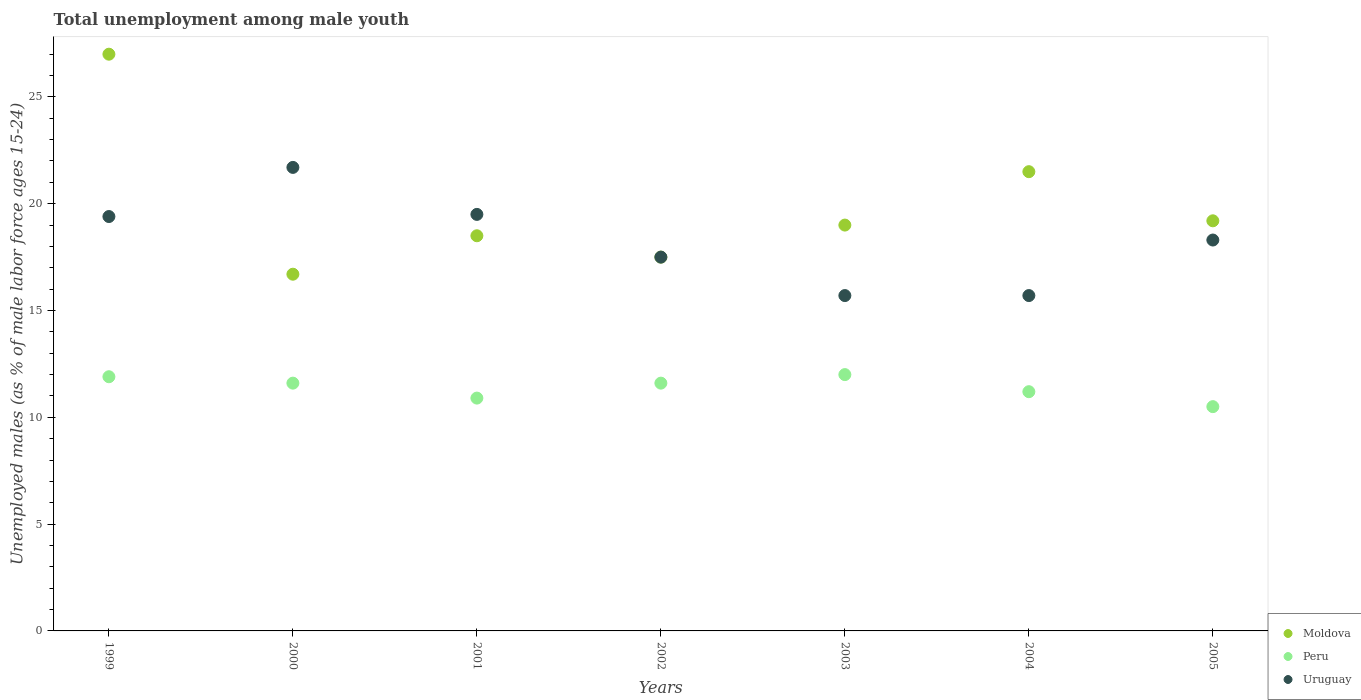How many different coloured dotlines are there?
Provide a short and direct response. 3. What is the percentage of unemployed males in in Peru in 2004?
Ensure brevity in your answer.  11.2. Across all years, what is the maximum percentage of unemployed males in in Moldova?
Keep it short and to the point. 27. Across all years, what is the minimum percentage of unemployed males in in Uruguay?
Your response must be concise. 15.7. In which year was the percentage of unemployed males in in Uruguay minimum?
Ensure brevity in your answer.  2003. What is the total percentage of unemployed males in in Moldova in the graph?
Keep it short and to the point. 139.4. What is the difference between the percentage of unemployed males in in Uruguay in 2000 and that in 2004?
Your response must be concise. 6. What is the difference between the percentage of unemployed males in in Moldova in 2000 and the percentage of unemployed males in in Uruguay in 2001?
Offer a very short reply. -2.8. What is the average percentage of unemployed males in in Peru per year?
Keep it short and to the point. 11.39. In the year 2003, what is the difference between the percentage of unemployed males in in Uruguay and percentage of unemployed males in in Moldova?
Make the answer very short. -3.3. In how many years, is the percentage of unemployed males in in Peru greater than 26 %?
Provide a short and direct response. 0. What is the ratio of the percentage of unemployed males in in Moldova in 2000 to that in 2004?
Ensure brevity in your answer.  0.78. Is the percentage of unemployed males in in Moldova in 2001 less than that in 2002?
Make the answer very short. No. Is the difference between the percentage of unemployed males in in Uruguay in 2004 and 2005 greater than the difference between the percentage of unemployed males in in Moldova in 2004 and 2005?
Offer a very short reply. No. What is the difference between the highest and the second highest percentage of unemployed males in in Peru?
Provide a short and direct response. 0.1. What is the difference between the highest and the lowest percentage of unemployed males in in Peru?
Give a very brief answer. 1.5. In how many years, is the percentage of unemployed males in in Uruguay greater than the average percentage of unemployed males in in Uruguay taken over all years?
Offer a very short reply. 4. Is the sum of the percentage of unemployed males in in Peru in 1999 and 2000 greater than the maximum percentage of unemployed males in in Moldova across all years?
Make the answer very short. No. Is the percentage of unemployed males in in Uruguay strictly greater than the percentage of unemployed males in in Peru over the years?
Make the answer very short. Yes. Is the percentage of unemployed males in in Moldova strictly less than the percentage of unemployed males in in Peru over the years?
Offer a very short reply. No. How many years are there in the graph?
Give a very brief answer. 7. Does the graph contain any zero values?
Your answer should be compact. No. Does the graph contain grids?
Your response must be concise. No. Where does the legend appear in the graph?
Make the answer very short. Bottom right. How are the legend labels stacked?
Make the answer very short. Vertical. What is the title of the graph?
Your answer should be compact. Total unemployment among male youth. What is the label or title of the X-axis?
Offer a terse response. Years. What is the label or title of the Y-axis?
Offer a very short reply. Unemployed males (as % of male labor force ages 15-24). What is the Unemployed males (as % of male labor force ages 15-24) of Peru in 1999?
Your answer should be very brief. 11.9. What is the Unemployed males (as % of male labor force ages 15-24) of Uruguay in 1999?
Give a very brief answer. 19.4. What is the Unemployed males (as % of male labor force ages 15-24) of Moldova in 2000?
Your answer should be compact. 16.7. What is the Unemployed males (as % of male labor force ages 15-24) of Peru in 2000?
Give a very brief answer. 11.6. What is the Unemployed males (as % of male labor force ages 15-24) of Uruguay in 2000?
Keep it short and to the point. 21.7. What is the Unemployed males (as % of male labor force ages 15-24) in Peru in 2001?
Make the answer very short. 10.9. What is the Unemployed males (as % of male labor force ages 15-24) in Uruguay in 2001?
Your answer should be compact. 19.5. What is the Unemployed males (as % of male labor force ages 15-24) in Moldova in 2002?
Provide a succinct answer. 17.5. What is the Unemployed males (as % of male labor force ages 15-24) of Peru in 2002?
Your answer should be very brief. 11.6. What is the Unemployed males (as % of male labor force ages 15-24) in Uruguay in 2002?
Provide a short and direct response. 17.5. What is the Unemployed males (as % of male labor force ages 15-24) of Moldova in 2003?
Make the answer very short. 19. What is the Unemployed males (as % of male labor force ages 15-24) of Uruguay in 2003?
Ensure brevity in your answer.  15.7. What is the Unemployed males (as % of male labor force ages 15-24) in Peru in 2004?
Offer a terse response. 11.2. What is the Unemployed males (as % of male labor force ages 15-24) in Uruguay in 2004?
Your answer should be compact. 15.7. What is the Unemployed males (as % of male labor force ages 15-24) of Moldova in 2005?
Provide a short and direct response. 19.2. What is the Unemployed males (as % of male labor force ages 15-24) in Peru in 2005?
Offer a terse response. 10.5. What is the Unemployed males (as % of male labor force ages 15-24) in Uruguay in 2005?
Keep it short and to the point. 18.3. Across all years, what is the maximum Unemployed males (as % of male labor force ages 15-24) of Moldova?
Your answer should be very brief. 27. Across all years, what is the maximum Unemployed males (as % of male labor force ages 15-24) in Peru?
Keep it short and to the point. 12. Across all years, what is the maximum Unemployed males (as % of male labor force ages 15-24) in Uruguay?
Provide a succinct answer. 21.7. Across all years, what is the minimum Unemployed males (as % of male labor force ages 15-24) in Moldova?
Offer a very short reply. 16.7. Across all years, what is the minimum Unemployed males (as % of male labor force ages 15-24) in Uruguay?
Ensure brevity in your answer.  15.7. What is the total Unemployed males (as % of male labor force ages 15-24) in Moldova in the graph?
Your response must be concise. 139.4. What is the total Unemployed males (as % of male labor force ages 15-24) in Peru in the graph?
Your response must be concise. 79.7. What is the total Unemployed males (as % of male labor force ages 15-24) in Uruguay in the graph?
Your answer should be compact. 127.8. What is the difference between the Unemployed males (as % of male labor force ages 15-24) of Peru in 1999 and that in 2000?
Provide a succinct answer. 0.3. What is the difference between the Unemployed males (as % of male labor force ages 15-24) in Moldova in 1999 and that in 2001?
Keep it short and to the point. 8.5. What is the difference between the Unemployed males (as % of male labor force ages 15-24) of Peru in 1999 and that in 2001?
Offer a very short reply. 1. What is the difference between the Unemployed males (as % of male labor force ages 15-24) in Moldova in 1999 and that in 2002?
Your response must be concise. 9.5. What is the difference between the Unemployed males (as % of male labor force ages 15-24) in Peru in 1999 and that in 2003?
Give a very brief answer. -0.1. What is the difference between the Unemployed males (as % of male labor force ages 15-24) in Moldova in 1999 and that in 2004?
Keep it short and to the point. 5.5. What is the difference between the Unemployed males (as % of male labor force ages 15-24) in Peru in 1999 and that in 2004?
Give a very brief answer. 0.7. What is the difference between the Unemployed males (as % of male labor force ages 15-24) of Uruguay in 1999 and that in 2004?
Ensure brevity in your answer.  3.7. What is the difference between the Unemployed males (as % of male labor force ages 15-24) of Peru in 1999 and that in 2005?
Your answer should be compact. 1.4. What is the difference between the Unemployed males (as % of male labor force ages 15-24) of Moldova in 2000 and that in 2001?
Keep it short and to the point. -1.8. What is the difference between the Unemployed males (as % of male labor force ages 15-24) of Peru in 2000 and that in 2001?
Make the answer very short. 0.7. What is the difference between the Unemployed males (as % of male labor force ages 15-24) of Uruguay in 2000 and that in 2002?
Give a very brief answer. 4.2. What is the difference between the Unemployed males (as % of male labor force ages 15-24) in Moldova in 2000 and that in 2003?
Your response must be concise. -2.3. What is the difference between the Unemployed males (as % of male labor force ages 15-24) of Peru in 2000 and that in 2003?
Give a very brief answer. -0.4. What is the difference between the Unemployed males (as % of male labor force ages 15-24) in Uruguay in 2000 and that in 2003?
Offer a very short reply. 6. What is the difference between the Unemployed males (as % of male labor force ages 15-24) in Uruguay in 2000 and that in 2004?
Make the answer very short. 6. What is the difference between the Unemployed males (as % of male labor force ages 15-24) in Uruguay in 2000 and that in 2005?
Give a very brief answer. 3.4. What is the difference between the Unemployed males (as % of male labor force ages 15-24) in Moldova in 2001 and that in 2002?
Make the answer very short. 1. What is the difference between the Unemployed males (as % of male labor force ages 15-24) in Peru in 2001 and that in 2002?
Offer a terse response. -0.7. What is the difference between the Unemployed males (as % of male labor force ages 15-24) of Peru in 2001 and that in 2003?
Give a very brief answer. -1.1. What is the difference between the Unemployed males (as % of male labor force ages 15-24) in Moldova in 2001 and that in 2004?
Your response must be concise. -3. What is the difference between the Unemployed males (as % of male labor force ages 15-24) of Moldova in 2001 and that in 2005?
Make the answer very short. -0.7. What is the difference between the Unemployed males (as % of male labor force ages 15-24) in Peru in 2001 and that in 2005?
Keep it short and to the point. 0.4. What is the difference between the Unemployed males (as % of male labor force ages 15-24) in Peru in 2002 and that in 2003?
Give a very brief answer. -0.4. What is the difference between the Unemployed males (as % of male labor force ages 15-24) in Moldova in 2002 and that in 2004?
Give a very brief answer. -4. What is the difference between the Unemployed males (as % of male labor force ages 15-24) of Moldova in 2002 and that in 2005?
Keep it short and to the point. -1.7. What is the difference between the Unemployed males (as % of male labor force ages 15-24) of Peru in 2002 and that in 2005?
Make the answer very short. 1.1. What is the difference between the Unemployed males (as % of male labor force ages 15-24) of Moldova in 2003 and that in 2004?
Make the answer very short. -2.5. What is the difference between the Unemployed males (as % of male labor force ages 15-24) of Uruguay in 2003 and that in 2005?
Your response must be concise. -2.6. What is the difference between the Unemployed males (as % of male labor force ages 15-24) in Peru in 2004 and that in 2005?
Your answer should be compact. 0.7. What is the difference between the Unemployed males (as % of male labor force ages 15-24) of Peru in 1999 and the Unemployed males (as % of male labor force ages 15-24) of Uruguay in 2001?
Provide a short and direct response. -7.6. What is the difference between the Unemployed males (as % of male labor force ages 15-24) of Moldova in 1999 and the Unemployed males (as % of male labor force ages 15-24) of Uruguay in 2002?
Your answer should be very brief. 9.5. What is the difference between the Unemployed males (as % of male labor force ages 15-24) of Moldova in 1999 and the Unemployed males (as % of male labor force ages 15-24) of Peru in 2003?
Ensure brevity in your answer.  15. What is the difference between the Unemployed males (as % of male labor force ages 15-24) in Moldova in 1999 and the Unemployed males (as % of male labor force ages 15-24) in Uruguay in 2003?
Ensure brevity in your answer.  11.3. What is the difference between the Unemployed males (as % of male labor force ages 15-24) of Peru in 1999 and the Unemployed males (as % of male labor force ages 15-24) of Uruguay in 2003?
Provide a succinct answer. -3.8. What is the difference between the Unemployed males (as % of male labor force ages 15-24) of Peru in 1999 and the Unemployed males (as % of male labor force ages 15-24) of Uruguay in 2004?
Your answer should be very brief. -3.8. What is the difference between the Unemployed males (as % of male labor force ages 15-24) of Moldova in 1999 and the Unemployed males (as % of male labor force ages 15-24) of Uruguay in 2005?
Your answer should be very brief. 8.7. What is the difference between the Unemployed males (as % of male labor force ages 15-24) of Moldova in 2000 and the Unemployed males (as % of male labor force ages 15-24) of Peru in 2001?
Offer a very short reply. 5.8. What is the difference between the Unemployed males (as % of male labor force ages 15-24) in Moldova in 2000 and the Unemployed males (as % of male labor force ages 15-24) in Uruguay in 2001?
Your response must be concise. -2.8. What is the difference between the Unemployed males (as % of male labor force ages 15-24) of Moldova in 2000 and the Unemployed males (as % of male labor force ages 15-24) of Peru in 2002?
Your answer should be compact. 5.1. What is the difference between the Unemployed males (as % of male labor force ages 15-24) of Moldova in 2000 and the Unemployed males (as % of male labor force ages 15-24) of Peru in 2003?
Offer a very short reply. 4.7. What is the difference between the Unemployed males (as % of male labor force ages 15-24) of Peru in 2000 and the Unemployed males (as % of male labor force ages 15-24) of Uruguay in 2003?
Your answer should be compact. -4.1. What is the difference between the Unemployed males (as % of male labor force ages 15-24) of Moldova in 2000 and the Unemployed males (as % of male labor force ages 15-24) of Peru in 2004?
Your answer should be very brief. 5.5. What is the difference between the Unemployed males (as % of male labor force ages 15-24) in Moldova in 2001 and the Unemployed males (as % of male labor force ages 15-24) in Peru in 2002?
Make the answer very short. 6.9. What is the difference between the Unemployed males (as % of male labor force ages 15-24) in Moldova in 2001 and the Unemployed males (as % of male labor force ages 15-24) in Uruguay in 2002?
Keep it short and to the point. 1. What is the difference between the Unemployed males (as % of male labor force ages 15-24) in Moldova in 2001 and the Unemployed males (as % of male labor force ages 15-24) in Peru in 2003?
Make the answer very short. 6.5. What is the difference between the Unemployed males (as % of male labor force ages 15-24) in Peru in 2001 and the Unemployed males (as % of male labor force ages 15-24) in Uruguay in 2003?
Offer a very short reply. -4.8. What is the difference between the Unemployed males (as % of male labor force ages 15-24) in Moldova in 2001 and the Unemployed males (as % of male labor force ages 15-24) in Peru in 2005?
Offer a terse response. 8. What is the difference between the Unemployed males (as % of male labor force ages 15-24) in Moldova in 2001 and the Unemployed males (as % of male labor force ages 15-24) in Uruguay in 2005?
Offer a terse response. 0.2. What is the difference between the Unemployed males (as % of male labor force ages 15-24) of Peru in 2001 and the Unemployed males (as % of male labor force ages 15-24) of Uruguay in 2005?
Ensure brevity in your answer.  -7.4. What is the difference between the Unemployed males (as % of male labor force ages 15-24) of Moldova in 2002 and the Unemployed males (as % of male labor force ages 15-24) of Uruguay in 2003?
Ensure brevity in your answer.  1.8. What is the difference between the Unemployed males (as % of male labor force ages 15-24) of Peru in 2002 and the Unemployed males (as % of male labor force ages 15-24) of Uruguay in 2003?
Your answer should be compact. -4.1. What is the difference between the Unemployed males (as % of male labor force ages 15-24) of Moldova in 2002 and the Unemployed males (as % of male labor force ages 15-24) of Peru in 2004?
Offer a very short reply. 6.3. What is the difference between the Unemployed males (as % of male labor force ages 15-24) of Moldova in 2002 and the Unemployed males (as % of male labor force ages 15-24) of Uruguay in 2004?
Offer a very short reply. 1.8. What is the difference between the Unemployed males (as % of male labor force ages 15-24) of Moldova in 2002 and the Unemployed males (as % of male labor force ages 15-24) of Uruguay in 2005?
Provide a succinct answer. -0.8. What is the difference between the Unemployed males (as % of male labor force ages 15-24) in Moldova in 2003 and the Unemployed males (as % of male labor force ages 15-24) in Peru in 2004?
Give a very brief answer. 7.8. What is the difference between the Unemployed males (as % of male labor force ages 15-24) of Moldova in 2003 and the Unemployed males (as % of male labor force ages 15-24) of Uruguay in 2004?
Provide a succinct answer. 3.3. What is the difference between the Unemployed males (as % of male labor force ages 15-24) of Peru in 2003 and the Unemployed males (as % of male labor force ages 15-24) of Uruguay in 2004?
Give a very brief answer. -3.7. What is the difference between the Unemployed males (as % of male labor force ages 15-24) in Moldova in 2003 and the Unemployed males (as % of male labor force ages 15-24) in Peru in 2005?
Offer a terse response. 8.5. What is the difference between the Unemployed males (as % of male labor force ages 15-24) in Peru in 2004 and the Unemployed males (as % of male labor force ages 15-24) in Uruguay in 2005?
Provide a succinct answer. -7.1. What is the average Unemployed males (as % of male labor force ages 15-24) of Moldova per year?
Give a very brief answer. 19.91. What is the average Unemployed males (as % of male labor force ages 15-24) of Peru per year?
Provide a succinct answer. 11.39. What is the average Unemployed males (as % of male labor force ages 15-24) of Uruguay per year?
Keep it short and to the point. 18.26. In the year 1999, what is the difference between the Unemployed males (as % of male labor force ages 15-24) of Moldova and Unemployed males (as % of male labor force ages 15-24) of Peru?
Your answer should be very brief. 15.1. In the year 2000, what is the difference between the Unemployed males (as % of male labor force ages 15-24) of Moldova and Unemployed males (as % of male labor force ages 15-24) of Peru?
Your answer should be compact. 5.1. In the year 2001, what is the difference between the Unemployed males (as % of male labor force ages 15-24) in Moldova and Unemployed males (as % of male labor force ages 15-24) in Uruguay?
Your answer should be very brief. -1. In the year 2001, what is the difference between the Unemployed males (as % of male labor force ages 15-24) of Peru and Unemployed males (as % of male labor force ages 15-24) of Uruguay?
Give a very brief answer. -8.6. In the year 2002, what is the difference between the Unemployed males (as % of male labor force ages 15-24) in Moldova and Unemployed males (as % of male labor force ages 15-24) in Peru?
Provide a succinct answer. 5.9. In the year 2002, what is the difference between the Unemployed males (as % of male labor force ages 15-24) in Moldova and Unemployed males (as % of male labor force ages 15-24) in Uruguay?
Make the answer very short. 0. In the year 2002, what is the difference between the Unemployed males (as % of male labor force ages 15-24) of Peru and Unemployed males (as % of male labor force ages 15-24) of Uruguay?
Offer a terse response. -5.9. In the year 2004, what is the difference between the Unemployed males (as % of male labor force ages 15-24) of Moldova and Unemployed males (as % of male labor force ages 15-24) of Peru?
Provide a short and direct response. 10.3. In the year 2004, what is the difference between the Unemployed males (as % of male labor force ages 15-24) of Moldova and Unemployed males (as % of male labor force ages 15-24) of Uruguay?
Ensure brevity in your answer.  5.8. In the year 2005, what is the difference between the Unemployed males (as % of male labor force ages 15-24) in Moldova and Unemployed males (as % of male labor force ages 15-24) in Uruguay?
Provide a succinct answer. 0.9. In the year 2005, what is the difference between the Unemployed males (as % of male labor force ages 15-24) of Peru and Unemployed males (as % of male labor force ages 15-24) of Uruguay?
Your response must be concise. -7.8. What is the ratio of the Unemployed males (as % of male labor force ages 15-24) of Moldova in 1999 to that in 2000?
Make the answer very short. 1.62. What is the ratio of the Unemployed males (as % of male labor force ages 15-24) in Peru in 1999 to that in 2000?
Your response must be concise. 1.03. What is the ratio of the Unemployed males (as % of male labor force ages 15-24) in Uruguay in 1999 to that in 2000?
Provide a short and direct response. 0.89. What is the ratio of the Unemployed males (as % of male labor force ages 15-24) of Moldova in 1999 to that in 2001?
Offer a terse response. 1.46. What is the ratio of the Unemployed males (as % of male labor force ages 15-24) in Peru in 1999 to that in 2001?
Give a very brief answer. 1.09. What is the ratio of the Unemployed males (as % of male labor force ages 15-24) in Uruguay in 1999 to that in 2001?
Your answer should be compact. 0.99. What is the ratio of the Unemployed males (as % of male labor force ages 15-24) in Moldova in 1999 to that in 2002?
Provide a succinct answer. 1.54. What is the ratio of the Unemployed males (as % of male labor force ages 15-24) of Peru in 1999 to that in 2002?
Provide a succinct answer. 1.03. What is the ratio of the Unemployed males (as % of male labor force ages 15-24) in Uruguay in 1999 to that in 2002?
Provide a short and direct response. 1.11. What is the ratio of the Unemployed males (as % of male labor force ages 15-24) of Moldova in 1999 to that in 2003?
Offer a very short reply. 1.42. What is the ratio of the Unemployed males (as % of male labor force ages 15-24) in Peru in 1999 to that in 2003?
Make the answer very short. 0.99. What is the ratio of the Unemployed males (as % of male labor force ages 15-24) in Uruguay in 1999 to that in 2003?
Provide a short and direct response. 1.24. What is the ratio of the Unemployed males (as % of male labor force ages 15-24) of Moldova in 1999 to that in 2004?
Your answer should be compact. 1.26. What is the ratio of the Unemployed males (as % of male labor force ages 15-24) of Peru in 1999 to that in 2004?
Ensure brevity in your answer.  1.06. What is the ratio of the Unemployed males (as % of male labor force ages 15-24) in Uruguay in 1999 to that in 2004?
Your response must be concise. 1.24. What is the ratio of the Unemployed males (as % of male labor force ages 15-24) of Moldova in 1999 to that in 2005?
Ensure brevity in your answer.  1.41. What is the ratio of the Unemployed males (as % of male labor force ages 15-24) in Peru in 1999 to that in 2005?
Offer a terse response. 1.13. What is the ratio of the Unemployed males (as % of male labor force ages 15-24) in Uruguay in 1999 to that in 2005?
Your answer should be very brief. 1.06. What is the ratio of the Unemployed males (as % of male labor force ages 15-24) in Moldova in 2000 to that in 2001?
Keep it short and to the point. 0.9. What is the ratio of the Unemployed males (as % of male labor force ages 15-24) of Peru in 2000 to that in 2001?
Make the answer very short. 1.06. What is the ratio of the Unemployed males (as % of male labor force ages 15-24) in Uruguay in 2000 to that in 2001?
Keep it short and to the point. 1.11. What is the ratio of the Unemployed males (as % of male labor force ages 15-24) of Moldova in 2000 to that in 2002?
Ensure brevity in your answer.  0.95. What is the ratio of the Unemployed males (as % of male labor force ages 15-24) in Uruguay in 2000 to that in 2002?
Keep it short and to the point. 1.24. What is the ratio of the Unemployed males (as % of male labor force ages 15-24) of Moldova in 2000 to that in 2003?
Ensure brevity in your answer.  0.88. What is the ratio of the Unemployed males (as % of male labor force ages 15-24) of Peru in 2000 to that in 2003?
Provide a succinct answer. 0.97. What is the ratio of the Unemployed males (as % of male labor force ages 15-24) of Uruguay in 2000 to that in 2003?
Ensure brevity in your answer.  1.38. What is the ratio of the Unemployed males (as % of male labor force ages 15-24) in Moldova in 2000 to that in 2004?
Keep it short and to the point. 0.78. What is the ratio of the Unemployed males (as % of male labor force ages 15-24) of Peru in 2000 to that in 2004?
Offer a very short reply. 1.04. What is the ratio of the Unemployed males (as % of male labor force ages 15-24) of Uruguay in 2000 to that in 2004?
Offer a very short reply. 1.38. What is the ratio of the Unemployed males (as % of male labor force ages 15-24) of Moldova in 2000 to that in 2005?
Give a very brief answer. 0.87. What is the ratio of the Unemployed males (as % of male labor force ages 15-24) of Peru in 2000 to that in 2005?
Your response must be concise. 1.1. What is the ratio of the Unemployed males (as % of male labor force ages 15-24) in Uruguay in 2000 to that in 2005?
Ensure brevity in your answer.  1.19. What is the ratio of the Unemployed males (as % of male labor force ages 15-24) in Moldova in 2001 to that in 2002?
Your answer should be compact. 1.06. What is the ratio of the Unemployed males (as % of male labor force ages 15-24) in Peru in 2001 to that in 2002?
Provide a short and direct response. 0.94. What is the ratio of the Unemployed males (as % of male labor force ages 15-24) in Uruguay in 2001 to that in 2002?
Keep it short and to the point. 1.11. What is the ratio of the Unemployed males (as % of male labor force ages 15-24) in Moldova in 2001 to that in 2003?
Provide a short and direct response. 0.97. What is the ratio of the Unemployed males (as % of male labor force ages 15-24) in Peru in 2001 to that in 2003?
Ensure brevity in your answer.  0.91. What is the ratio of the Unemployed males (as % of male labor force ages 15-24) of Uruguay in 2001 to that in 2003?
Make the answer very short. 1.24. What is the ratio of the Unemployed males (as % of male labor force ages 15-24) in Moldova in 2001 to that in 2004?
Provide a succinct answer. 0.86. What is the ratio of the Unemployed males (as % of male labor force ages 15-24) of Peru in 2001 to that in 2004?
Your answer should be compact. 0.97. What is the ratio of the Unemployed males (as % of male labor force ages 15-24) of Uruguay in 2001 to that in 2004?
Ensure brevity in your answer.  1.24. What is the ratio of the Unemployed males (as % of male labor force ages 15-24) of Moldova in 2001 to that in 2005?
Give a very brief answer. 0.96. What is the ratio of the Unemployed males (as % of male labor force ages 15-24) of Peru in 2001 to that in 2005?
Make the answer very short. 1.04. What is the ratio of the Unemployed males (as % of male labor force ages 15-24) of Uruguay in 2001 to that in 2005?
Offer a very short reply. 1.07. What is the ratio of the Unemployed males (as % of male labor force ages 15-24) in Moldova in 2002 to that in 2003?
Give a very brief answer. 0.92. What is the ratio of the Unemployed males (as % of male labor force ages 15-24) of Peru in 2002 to that in 2003?
Provide a short and direct response. 0.97. What is the ratio of the Unemployed males (as % of male labor force ages 15-24) in Uruguay in 2002 to that in 2003?
Ensure brevity in your answer.  1.11. What is the ratio of the Unemployed males (as % of male labor force ages 15-24) in Moldova in 2002 to that in 2004?
Offer a very short reply. 0.81. What is the ratio of the Unemployed males (as % of male labor force ages 15-24) of Peru in 2002 to that in 2004?
Your answer should be compact. 1.04. What is the ratio of the Unemployed males (as % of male labor force ages 15-24) in Uruguay in 2002 to that in 2004?
Provide a succinct answer. 1.11. What is the ratio of the Unemployed males (as % of male labor force ages 15-24) in Moldova in 2002 to that in 2005?
Provide a short and direct response. 0.91. What is the ratio of the Unemployed males (as % of male labor force ages 15-24) in Peru in 2002 to that in 2005?
Your answer should be compact. 1.1. What is the ratio of the Unemployed males (as % of male labor force ages 15-24) of Uruguay in 2002 to that in 2005?
Give a very brief answer. 0.96. What is the ratio of the Unemployed males (as % of male labor force ages 15-24) in Moldova in 2003 to that in 2004?
Your answer should be very brief. 0.88. What is the ratio of the Unemployed males (as % of male labor force ages 15-24) of Peru in 2003 to that in 2004?
Keep it short and to the point. 1.07. What is the ratio of the Unemployed males (as % of male labor force ages 15-24) of Peru in 2003 to that in 2005?
Give a very brief answer. 1.14. What is the ratio of the Unemployed males (as % of male labor force ages 15-24) in Uruguay in 2003 to that in 2005?
Provide a succinct answer. 0.86. What is the ratio of the Unemployed males (as % of male labor force ages 15-24) in Moldova in 2004 to that in 2005?
Provide a succinct answer. 1.12. What is the ratio of the Unemployed males (as % of male labor force ages 15-24) in Peru in 2004 to that in 2005?
Provide a succinct answer. 1.07. What is the ratio of the Unemployed males (as % of male labor force ages 15-24) in Uruguay in 2004 to that in 2005?
Ensure brevity in your answer.  0.86. What is the difference between the highest and the second highest Unemployed males (as % of male labor force ages 15-24) of Uruguay?
Your answer should be very brief. 2.2. What is the difference between the highest and the lowest Unemployed males (as % of male labor force ages 15-24) of Uruguay?
Give a very brief answer. 6. 